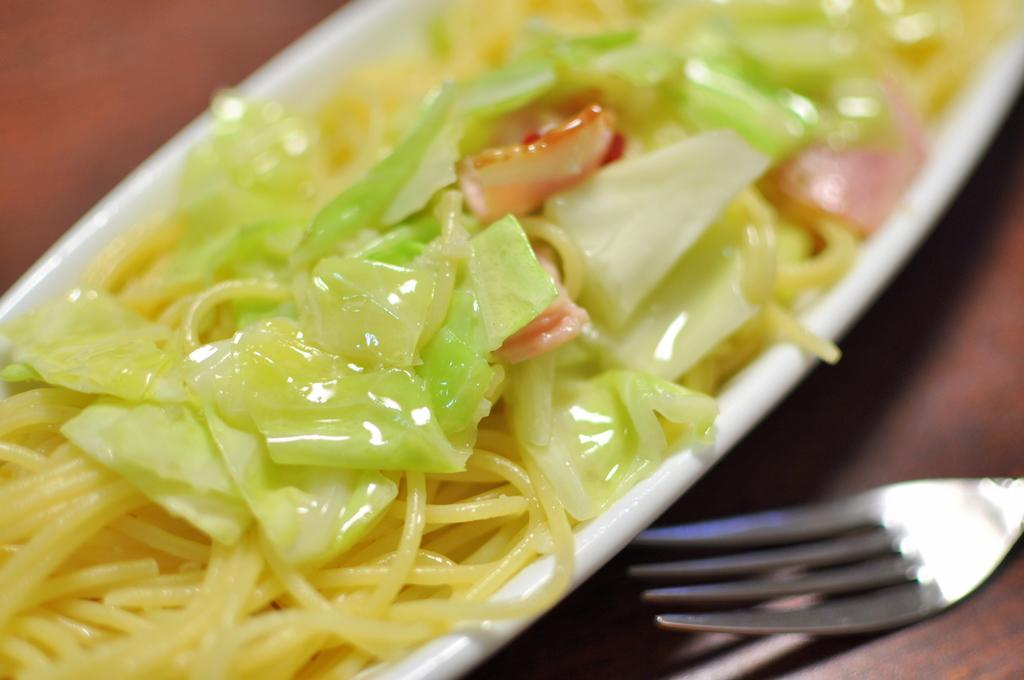What color is the plate that is visible in the image? The plate is white in color. What is on the plate in the image? There is food on the plate. What utensil is located beside the plate? There is a fork beside the plate. How many lizards can be seen crawling on the plate in the image? There are no lizards present in the image; it features a white color plate with food and a fork beside it. 